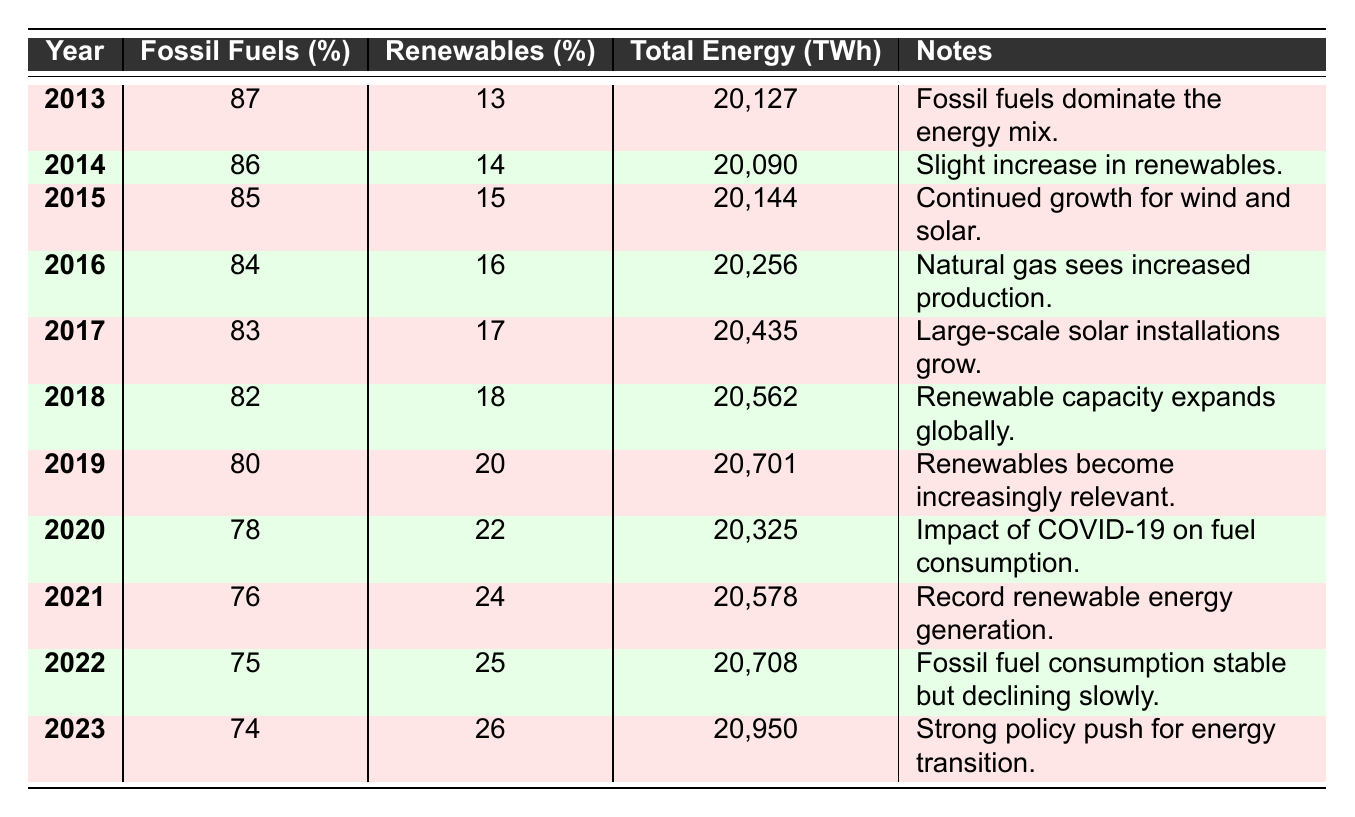What was the percentage of fossil fuels used in 2013? The table shows that in 2013, fossil fuels comprised 87% of energy production.
Answer: 87% What is the total energy produced in 2020? The table indicates that the total energy produced in 2020 was 20,325 TWh.
Answer: 20,325 TWh Was there a larger percentage increase in renewables from 2018 to 2019 or from 2022 to 2023? The increase in renewables from 2018 (18%) to 2019 (20%) is 2 percentage points, while from 2022 (25%) to 2023 (26%) is 1 percentage point. Therefore, the larger increase was from 2018 to 2019.
Answer: From 2018 to 2019 What was the average percentage of fossil fuels used in energy production from 2013 to 2022? To find the average, sum the fossil fuel percentages (87 + 86 + 85 + 84 + 83 + 82 + 80 + 78 + 76 + 75) =  825, then divide by 10 (the number of years) to get 82.5%.
Answer: 82.5% In which year did the percentage of renewables reach the highest value in this data? The highest percentage of renewables recorded is 26%, which occurred in 2023 according to the table.
Answer: 2023 Was there a decline in the fossil fuel percentage every year from 2013 to 2023? Yes, the percentage of fossil fuels consistently decreased each year as per the data shown in the table.
Answer: Yes What was the difference in total energy produced between 2014 and 2015? In 2014, the total energy produced was 20,090 TWh and in 2015 it was 20,144 TWh. The difference is 20,144 - 20,090 = 54 TWh.
Answer: 54 TWh Which year had the highest total energy produced? By examining the table, the highest total energy produced was in 2023 at 20,950 TWh.
Answer: 2023 In what year did renewable energy production surpass 20% for the first time? The data shows that renewables made up 20% of energy production in 2019. Since this is the first instance of renewables surpassing 20%, the answer is 2019.
Answer: 2019 